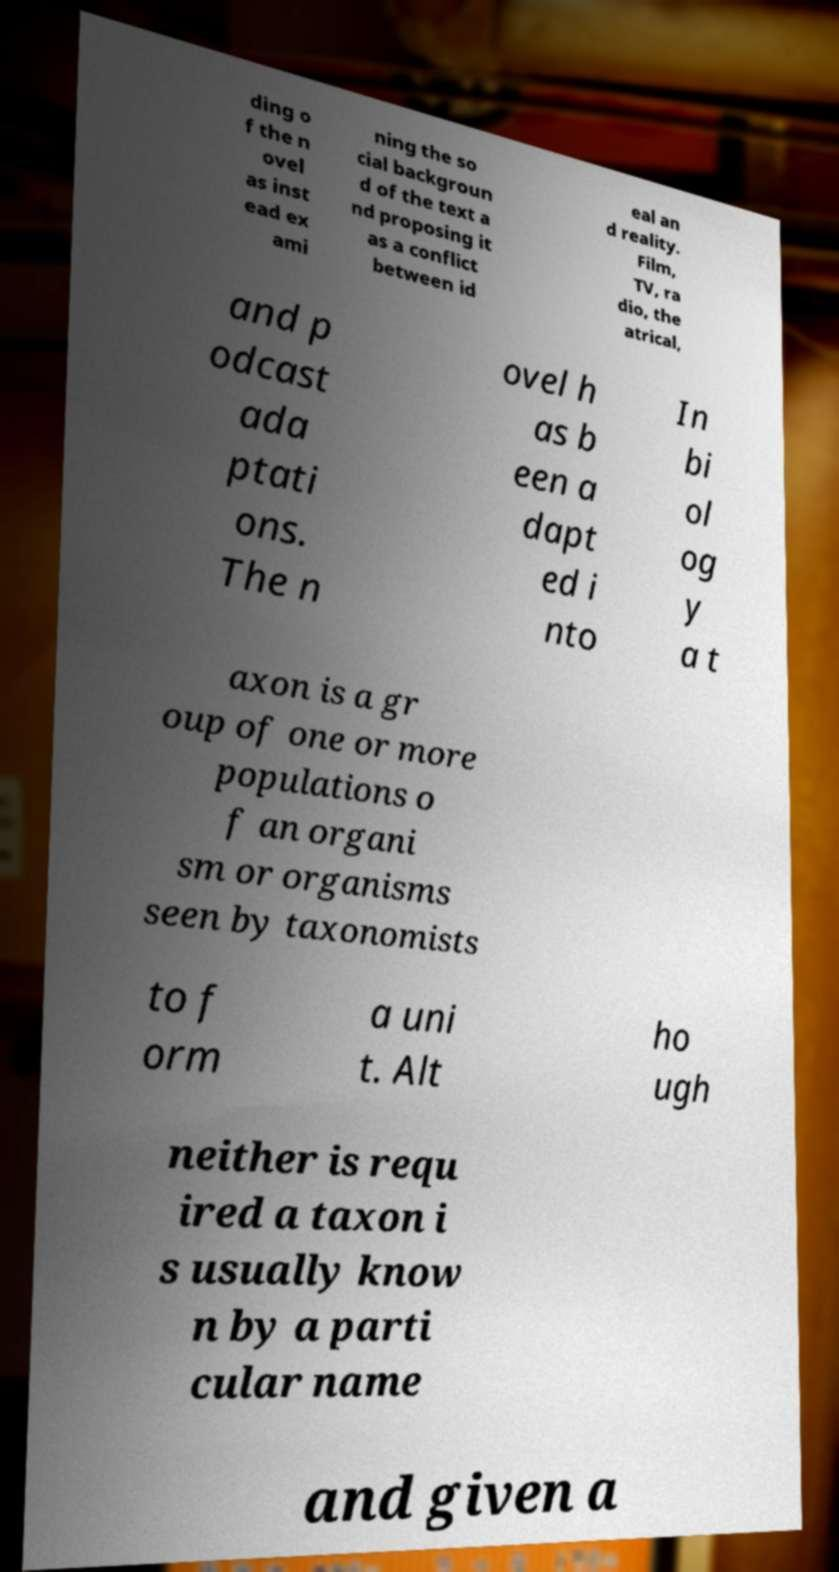Can you read and provide the text displayed in the image?This photo seems to have some interesting text. Can you extract and type it out for me? ding o f the n ovel as inst ead ex ami ning the so cial backgroun d of the text a nd proposing it as a conflict between id eal an d reality. Film, TV, ra dio, the atrical, and p odcast ada ptati ons. The n ovel h as b een a dapt ed i nto In bi ol og y a t axon is a gr oup of one or more populations o f an organi sm or organisms seen by taxonomists to f orm a uni t. Alt ho ugh neither is requ ired a taxon i s usually know n by a parti cular name and given a 